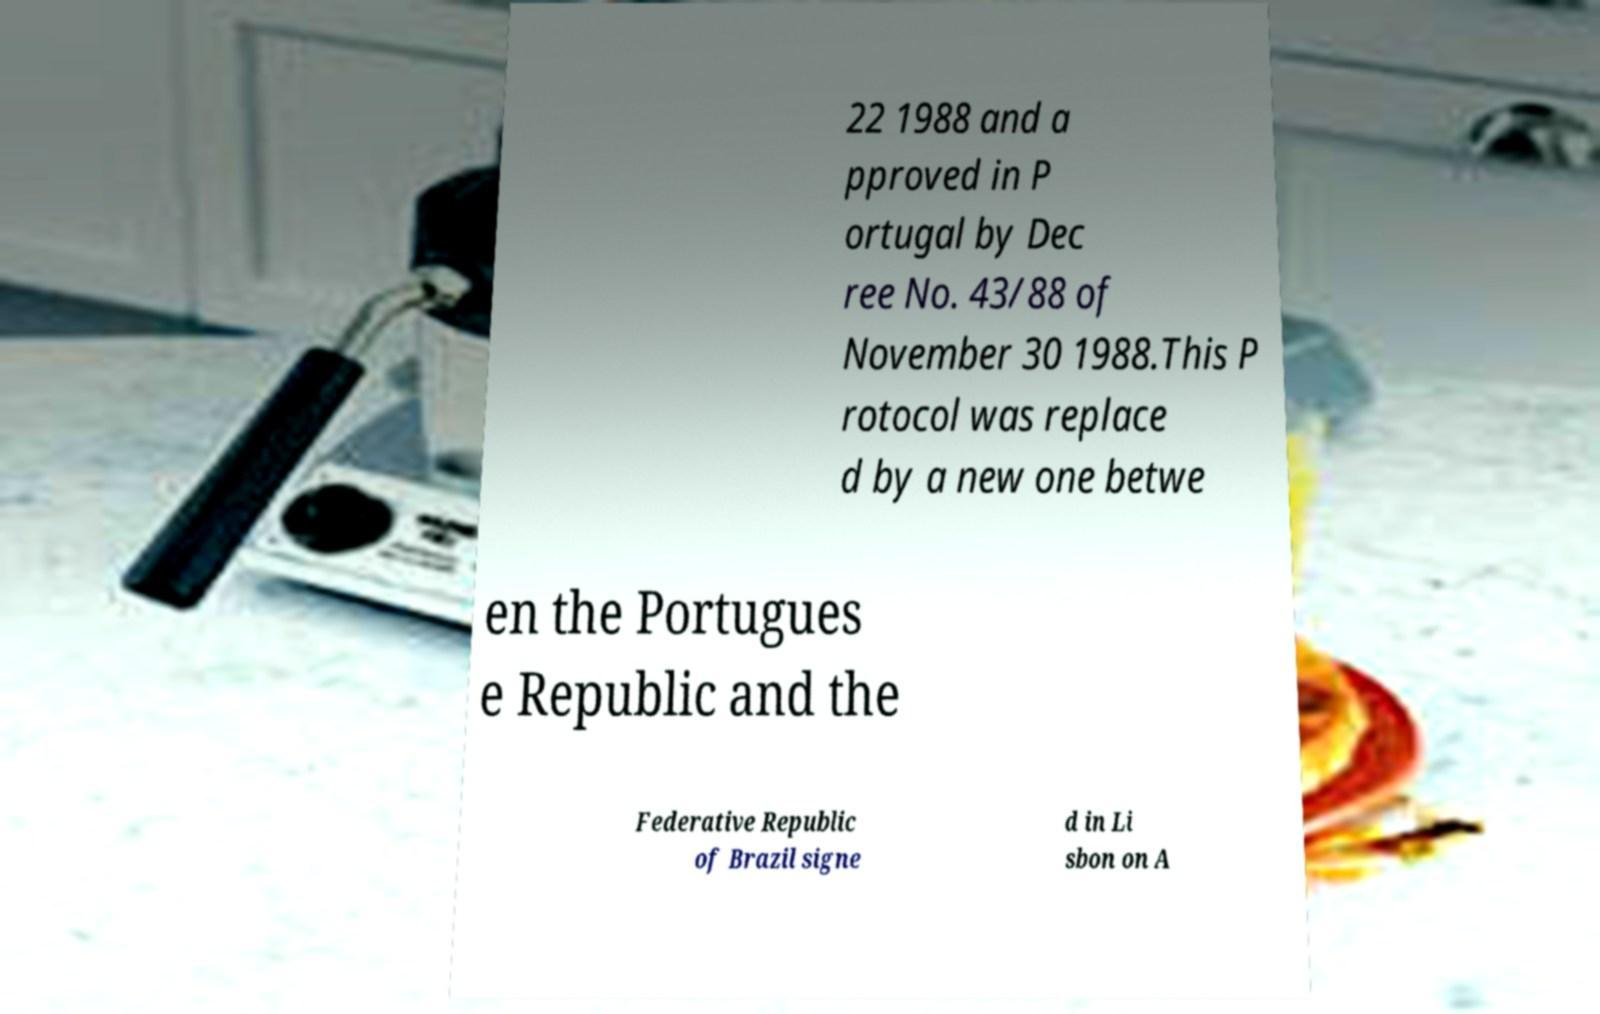Could you assist in decoding the text presented in this image and type it out clearly? 22 1988 and a pproved in P ortugal by Dec ree No. 43/88 of November 30 1988.This P rotocol was replace d by a new one betwe en the Portugues e Republic and the Federative Republic of Brazil signe d in Li sbon on A 